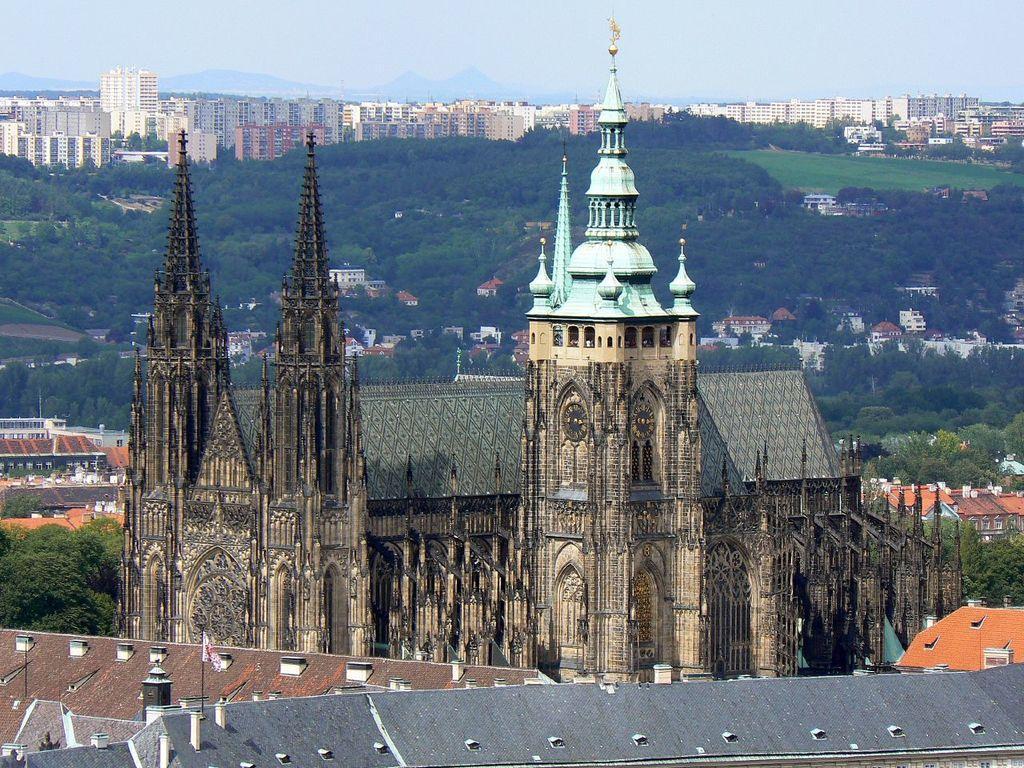Can you describe this image briefly? This is the picture of a city. There are buildings and trees. In the foreground there are clocks on the wall and there is a flag on the top of the building. At the back there are mountains. At the top there is sky. At the bottom there is grass. 